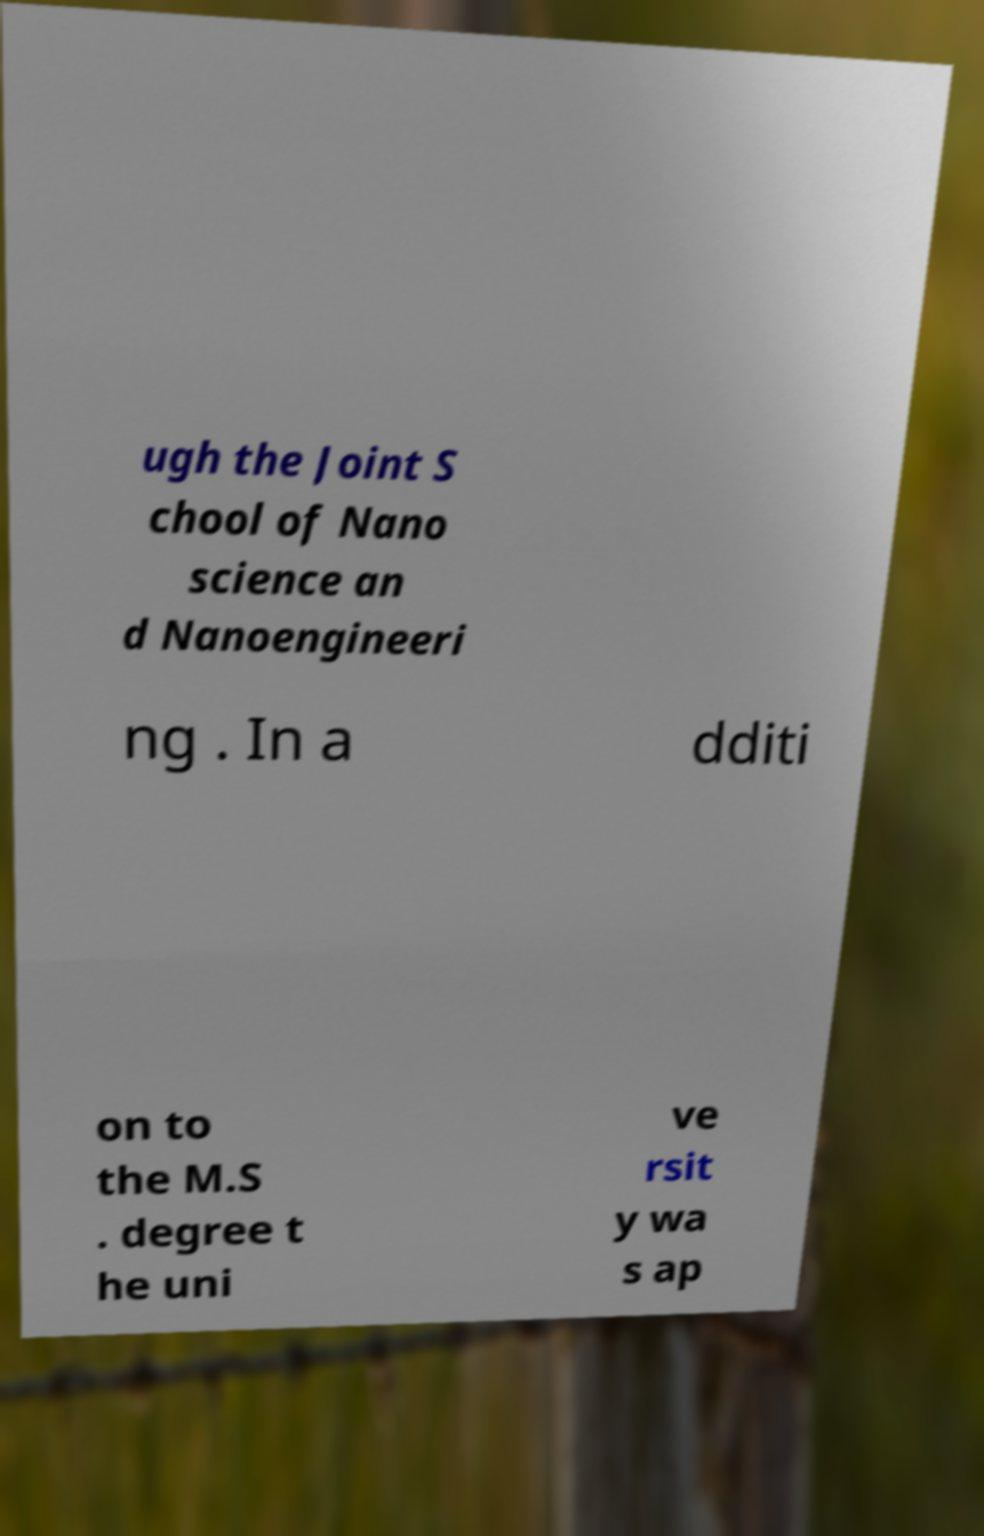I need the written content from this picture converted into text. Can you do that? ugh the Joint S chool of Nano science an d Nanoengineeri ng . In a dditi on to the M.S . degree t he uni ve rsit y wa s ap 